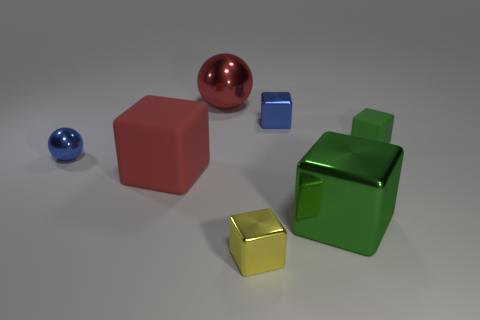What are the different colors of the objects in this image? The objects feature a variety of colors: there's a red cube, a blue sphere, a smaller blue cube, a green bottle-like shape, and a gold/yellow cube. How could these objects be used to demonstrate a concept? These objects could be used to demonstrate the concept of size and spatial relationships, color theory, or the principles of geometry and the characteristics of different 3D shapes. 